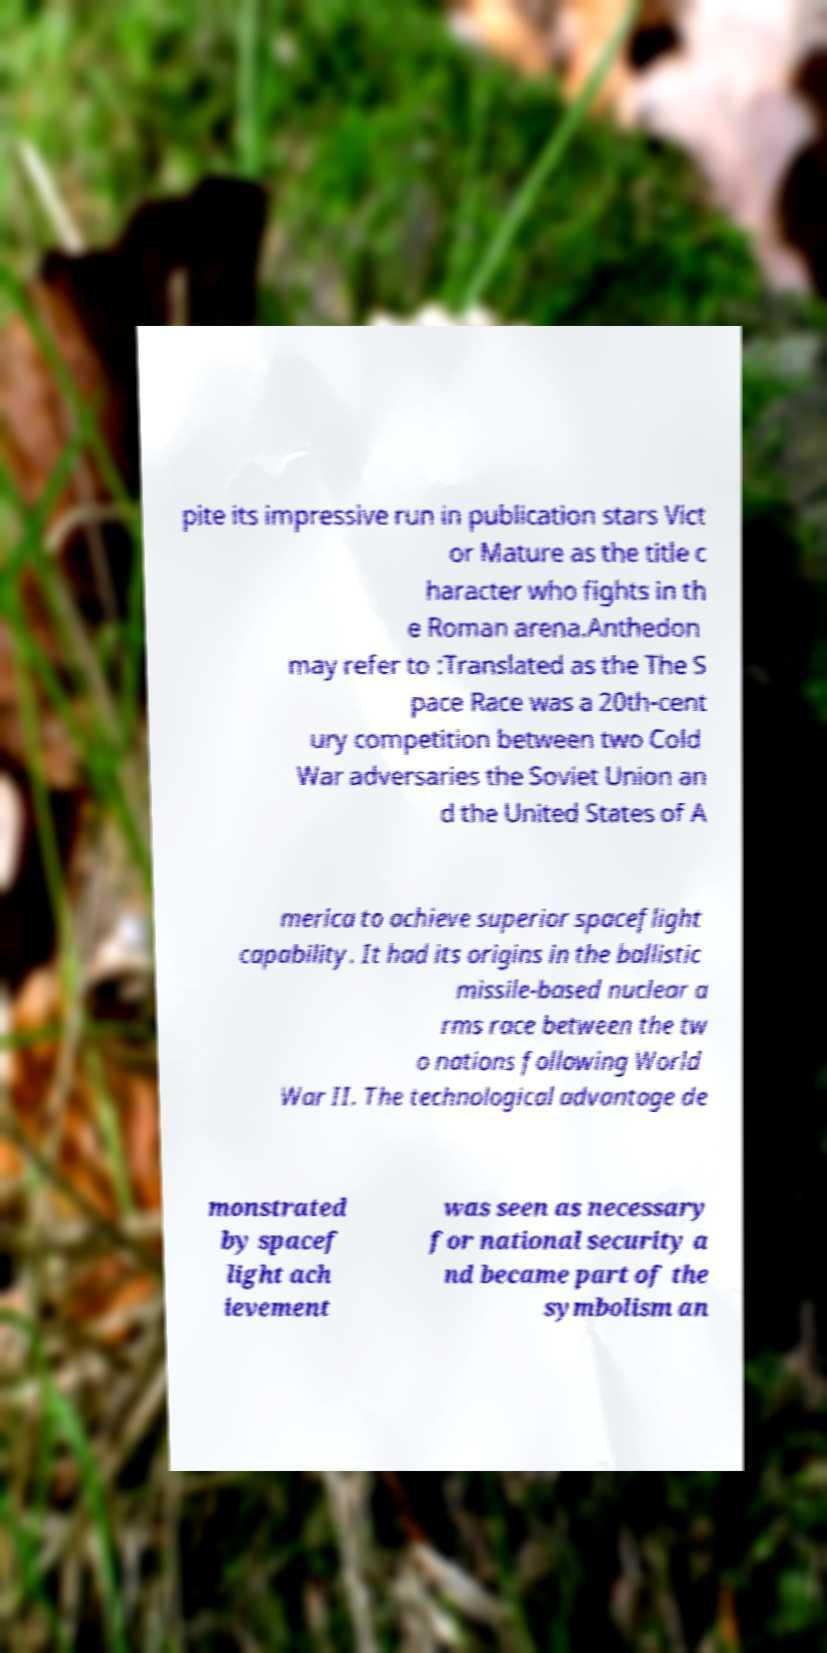Can you read and provide the text displayed in the image?This photo seems to have some interesting text. Can you extract and type it out for me? pite its impressive run in publication stars Vict or Mature as the title c haracter who fights in th e Roman arena.Anthedon may refer to :Translated as the The S pace Race was a 20th-cent ury competition between two Cold War adversaries the Soviet Union an d the United States of A merica to achieve superior spaceflight capability. It had its origins in the ballistic missile-based nuclear a rms race between the tw o nations following World War II. The technological advantage de monstrated by spacef light ach ievement was seen as necessary for national security a nd became part of the symbolism an 